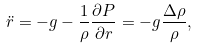Convert formula to latex. <formula><loc_0><loc_0><loc_500><loc_500>\ddot { r } = - g - \frac { 1 } { \rho } \frac { \partial P } { \partial r } = - g \frac { \Delta \rho } { \rho } ,</formula> 